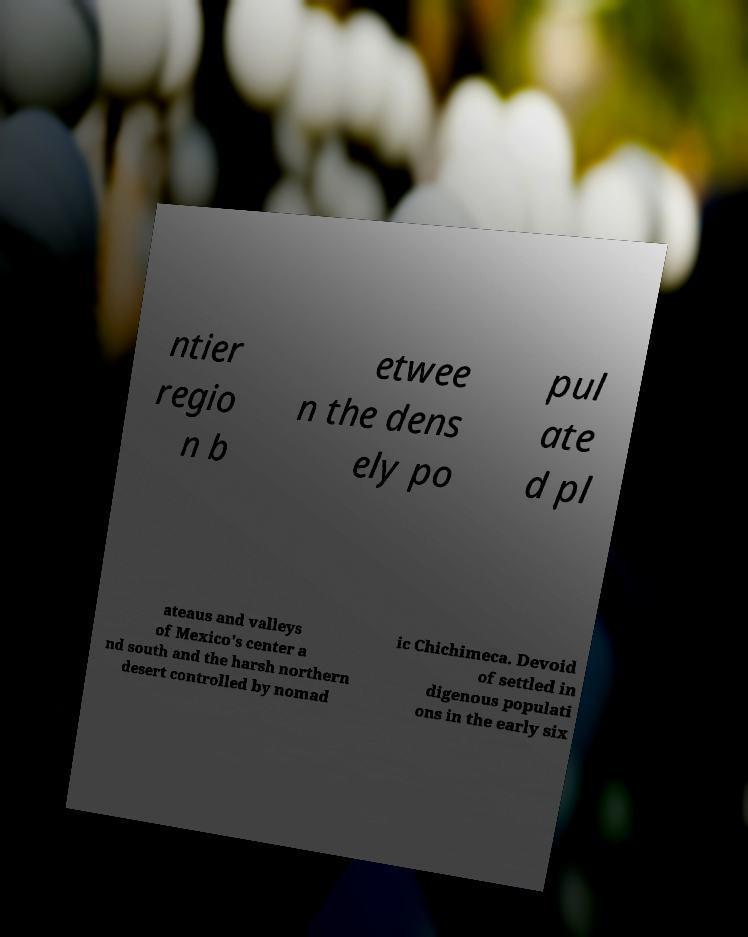I need the written content from this picture converted into text. Can you do that? ntier regio n b etwee n the dens ely po pul ate d pl ateaus and valleys of Mexico's center a nd south and the harsh northern desert controlled by nomad ic Chichimeca. Devoid of settled in digenous populati ons in the early six 